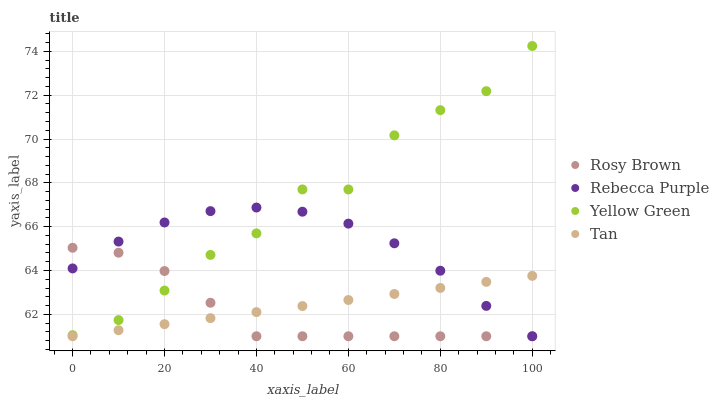Does Rosy Brown have the minimum area under the curve?
Answer yes or no. Yes. Does Yellow Green have the maximum area under the curve?
Answer yes or no. Yes. Does Rebecca Purple have the minimum area under the curve?
Answer yes or no. No. Does Rebecca Purple have the maximum area under the curve?
Answer yes or no. No. Is Tan the smoothest?
Answer yes or no. Yes. Is Yellow Green the roughest?
Answer yes or no. Yes. Is Rosy Brown the smoothest?
Answer yes or no. No. Is Rosy Brown the roughest?
Answer yes or no. No. Does Tan have the lowest value?
Answer yes or no. Yes. Does Yellow Green have the lowest value?
Answer yes or no. No. Does Yellow Green have the highest value?
Answer yes or no. Yes. Does Rosy Brown have the highest value?
Answer yes or no. No. Is Tan less than Yellow Green?
Answer yes or no. Yes. Is Yellow Green greater than Tan?
Answer yes or no. Yes. Does Rebecca Purple intersect Yellow Green?
Answer yes or no. Yes. Is Rebecca Purple less than Yellow Green?
Answer yes or no. No. Is Rebecca Purple greater than Yellow Green?
Answer yes or no. No. Does Tan intersect Yellow Green?
Answer yes or no. No. 